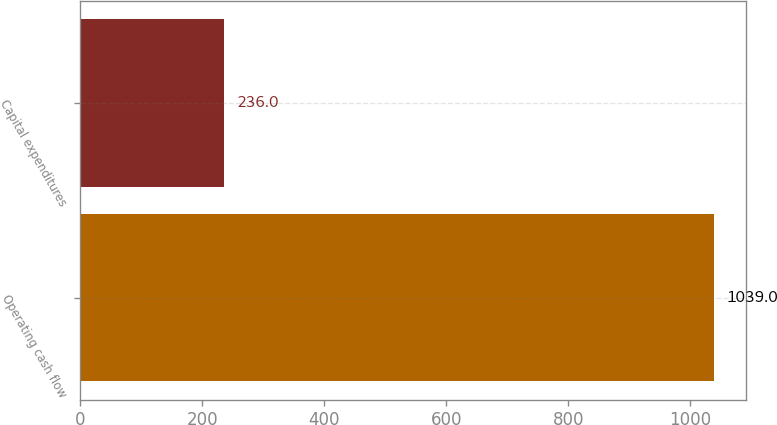Convert chart to OTSL. <chart><loc_0><loc_0><loc_500><loc_500><bar_chart><fcel>Operating cash flow<fcel>Capital expenditures<nl><fcel>1039<fcel>236<nl></chart> 